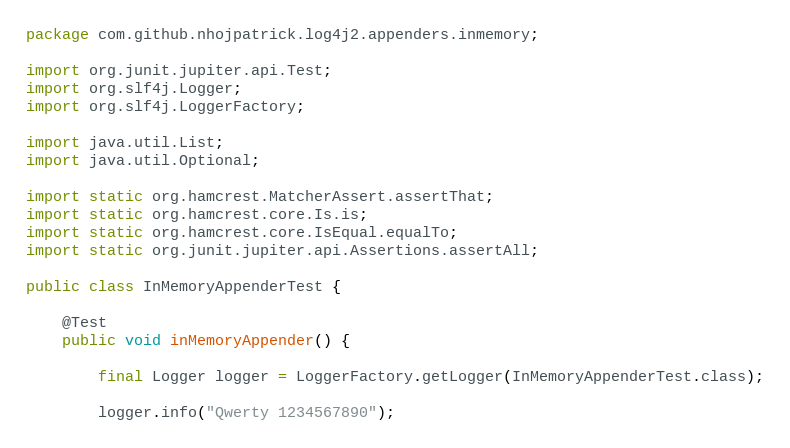<code> <loc_0><loc_0><loc_500><loc_500><_Java_>package com.github.nhojpatrick.log4j2.appenders.inmemory;

import org.junit.jupiter.api.Test;
import org.slf4j.Logger;
import org.slf4j.LoggerFactory;

import java.util.List;
import java.util.Optional;

import static org.hamcrest.MatcherAssert.assertThat;
import static org.hamcrest.core.Is.is;
import static org.hamcrest.core.IsEqual.equalTo;
import static org.junit.jupiter.api.Assertions.assertAll;

public class InMemoryAppenderTest {

    @Test
    public void inMemoryAppender() {

        final Logger logger = LoggerFactory.getLogger(InMemoryAppenderTest.class);

        logger.info("Qwerty 1234567890");
</code> 